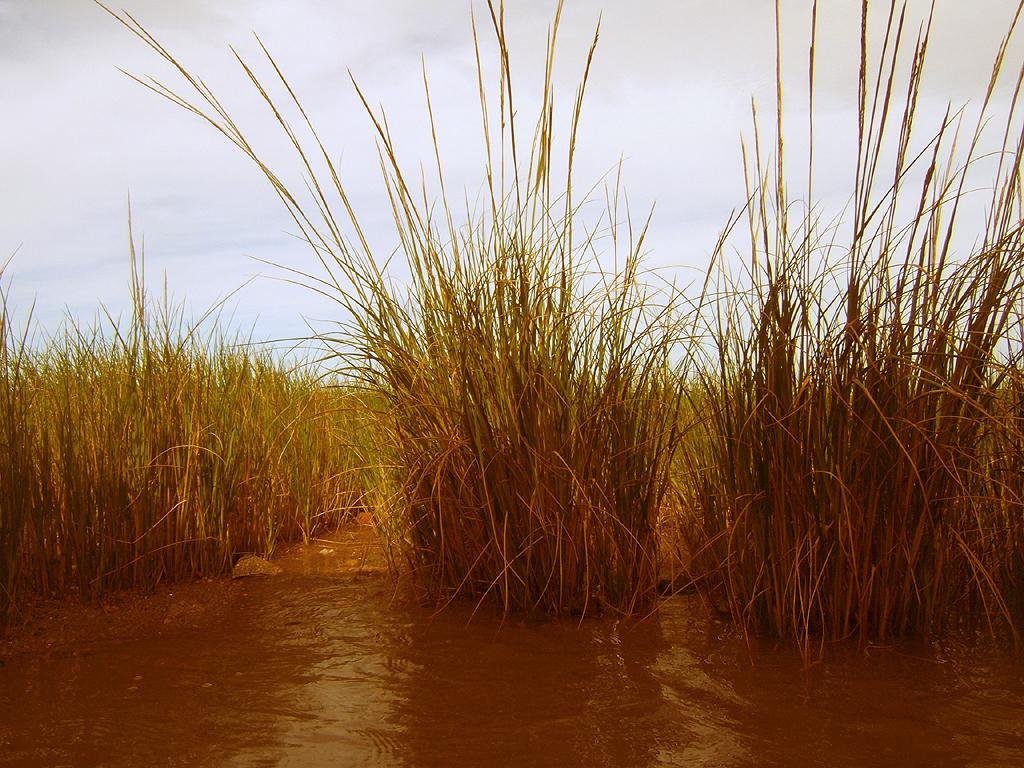What is present at the bottom of the image? There is water at the bottom of the image. What can be seen in the background of the image? There are plants in the background of the image. What is visible at the top of the image? The sky is visible at the top of the image. Can you tell me how many people are joining the branch in the image? There are no people or branches present in the image. What type of picture is hanging on the wall in the image? There is no mention of a picture or a wall in the image. 